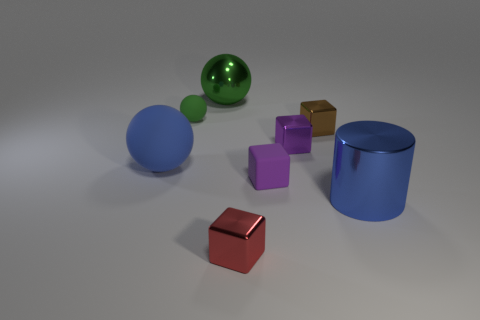Add 2 big green shiny spheres. How many objects exist? 10 Subtract all metallic balls. How many balls are left? 2 Subtract 2 balls. How many balls are left? 1 Subtract all purple cubes. How many cubes are left? 2 Subtract 0 yellow blocks. How many objects are left? 8 Subtract all cylinders. How many objects are left? 7 Subtract all purple balls. Subtract all red cubes. How many balls are left? 3 Subtract all yellow cylinders. How many blue spheres are left? 1 Subtract all small green matte spheres. Subtract all large rubber objects. How many objects are left? 6 Add 1 shiny blocks. How many shiny blocks are left? 4 